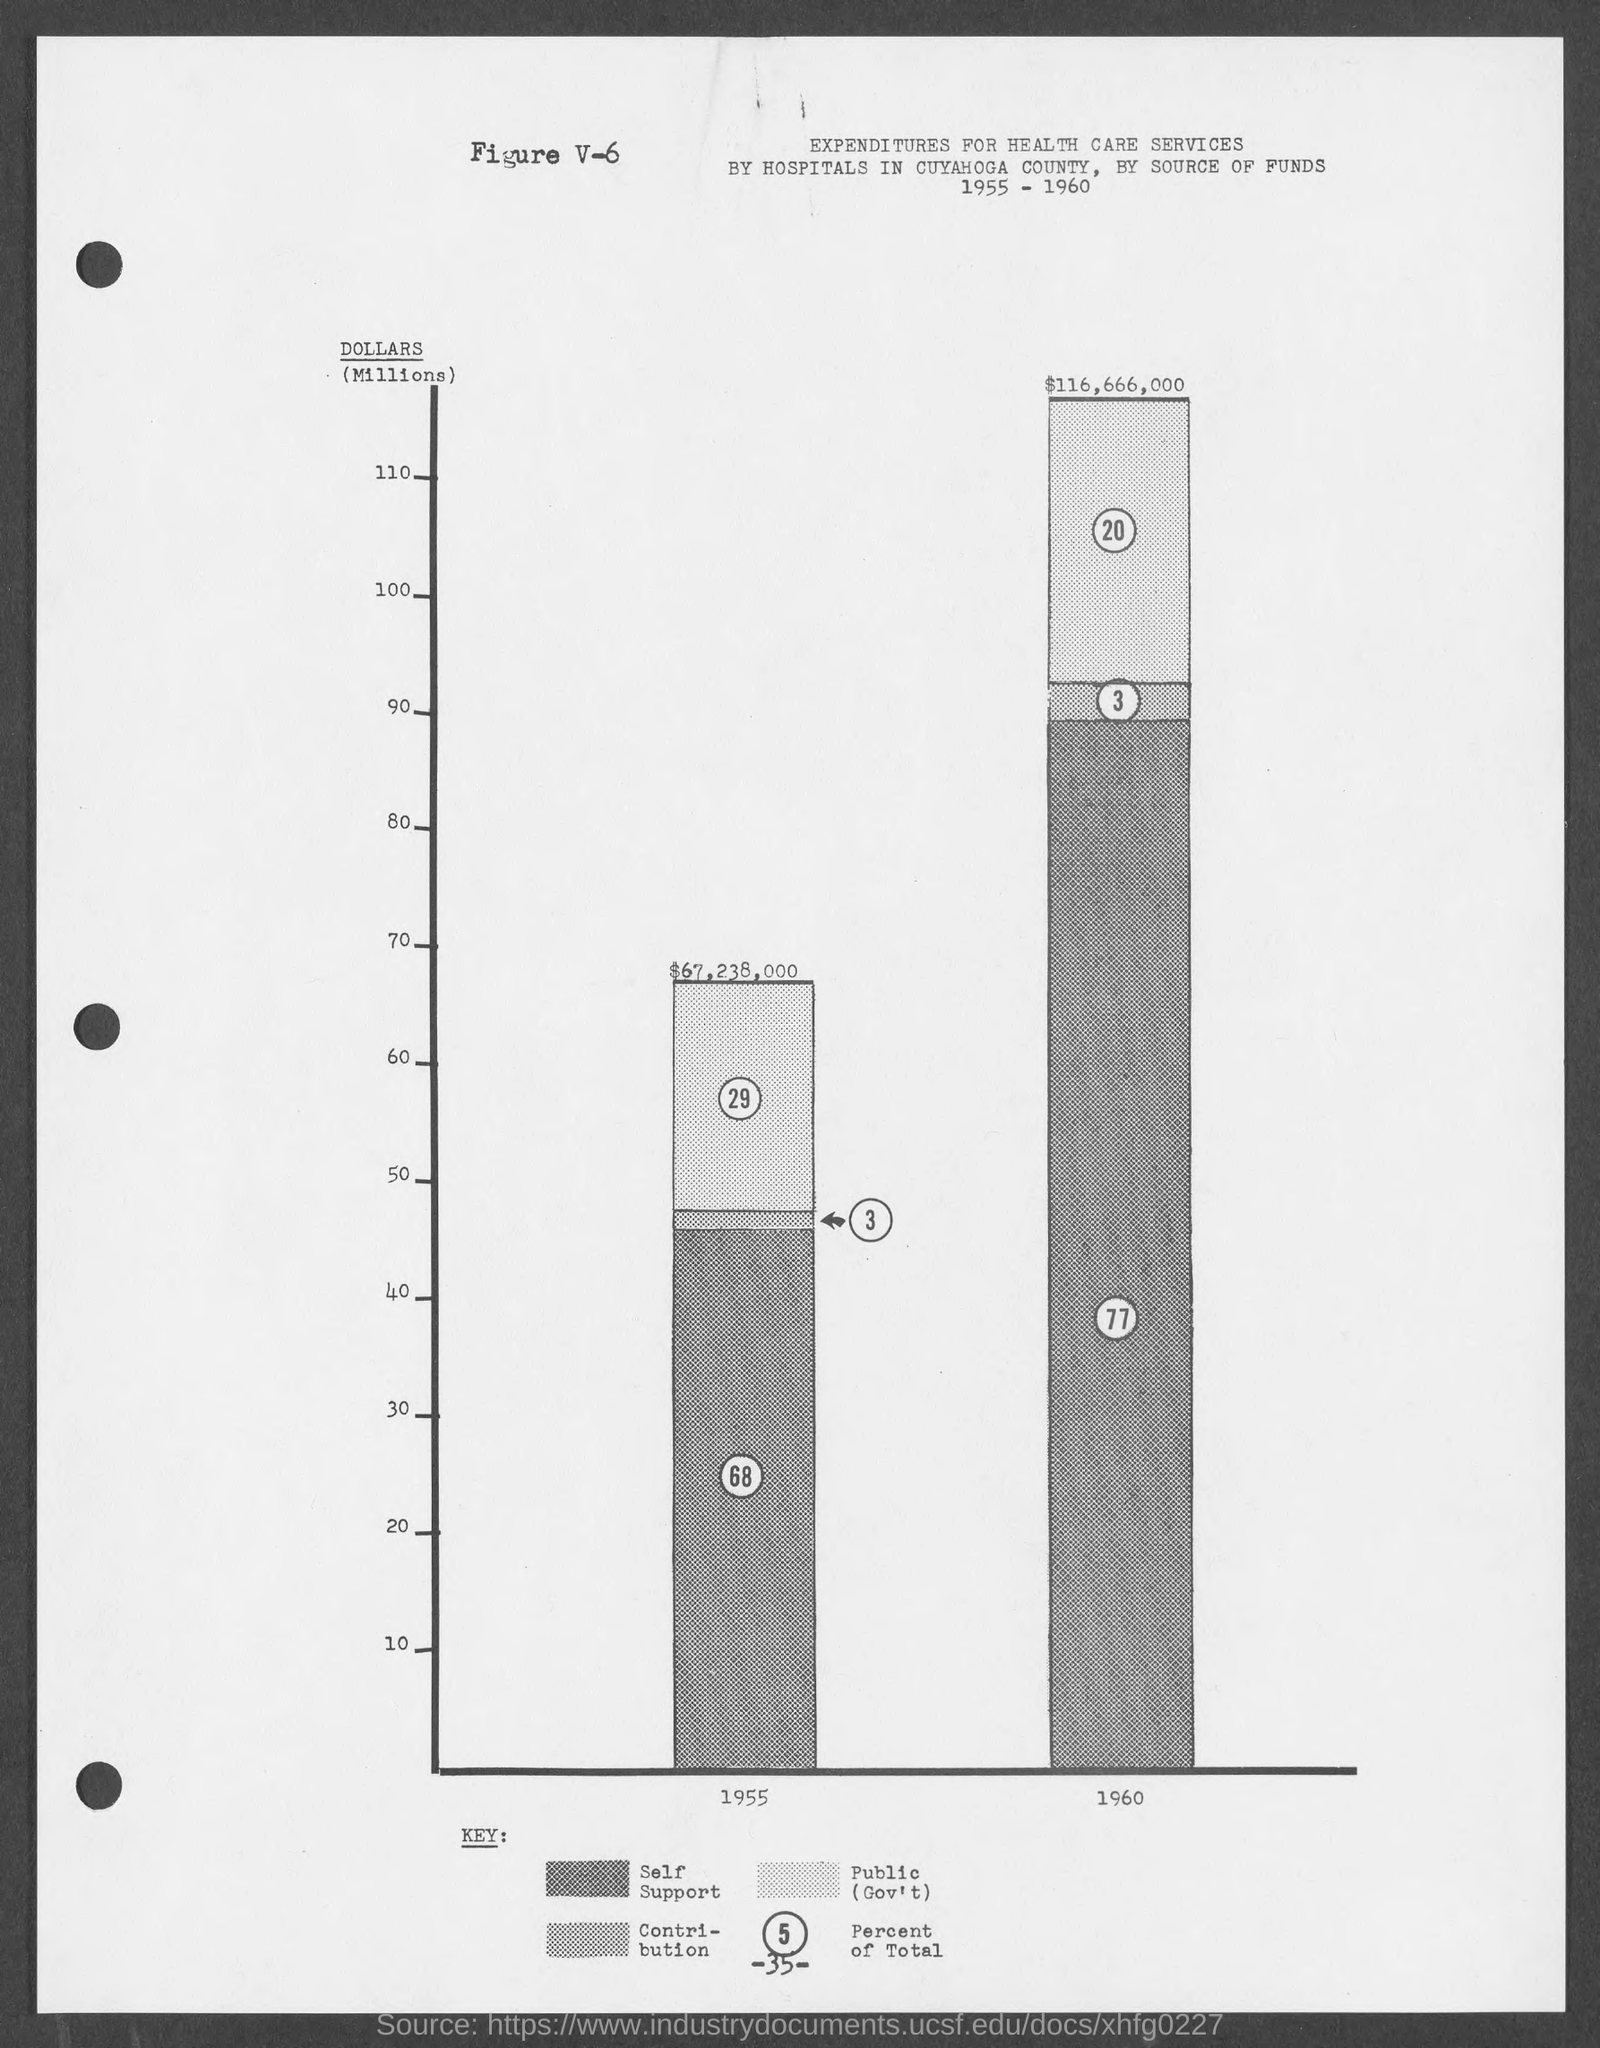Indicate a few pertinent items in this graphic. The number at the bottom of the page is -35. What is the figure number? V-6... 